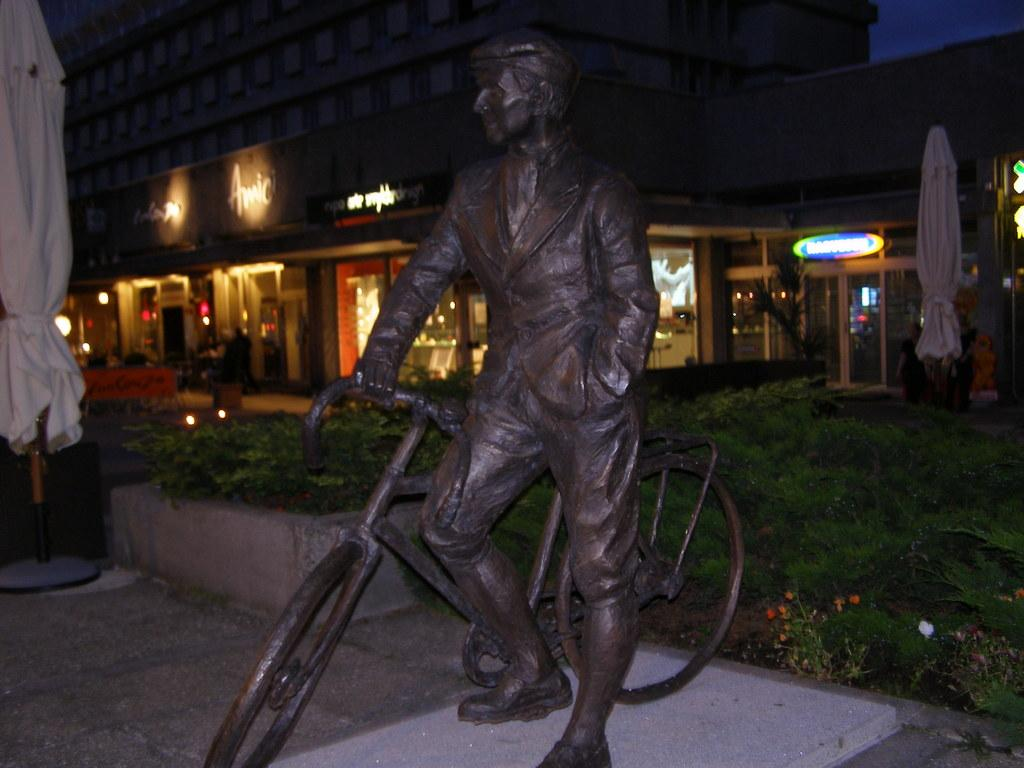What is the main subject in the foreground of the image? There is a statue in the foreground of the image. What can be seen in the background of the image? There are stores, umbrellas, plants, and light visible in the background of the image. Can you tell me how many berries are on the statue in the image? There are no berries present on the statue in the image. Is there a rabbit hiding among the plants in the background of the image? There is no rabbit visible among the plants in the background of the image. 